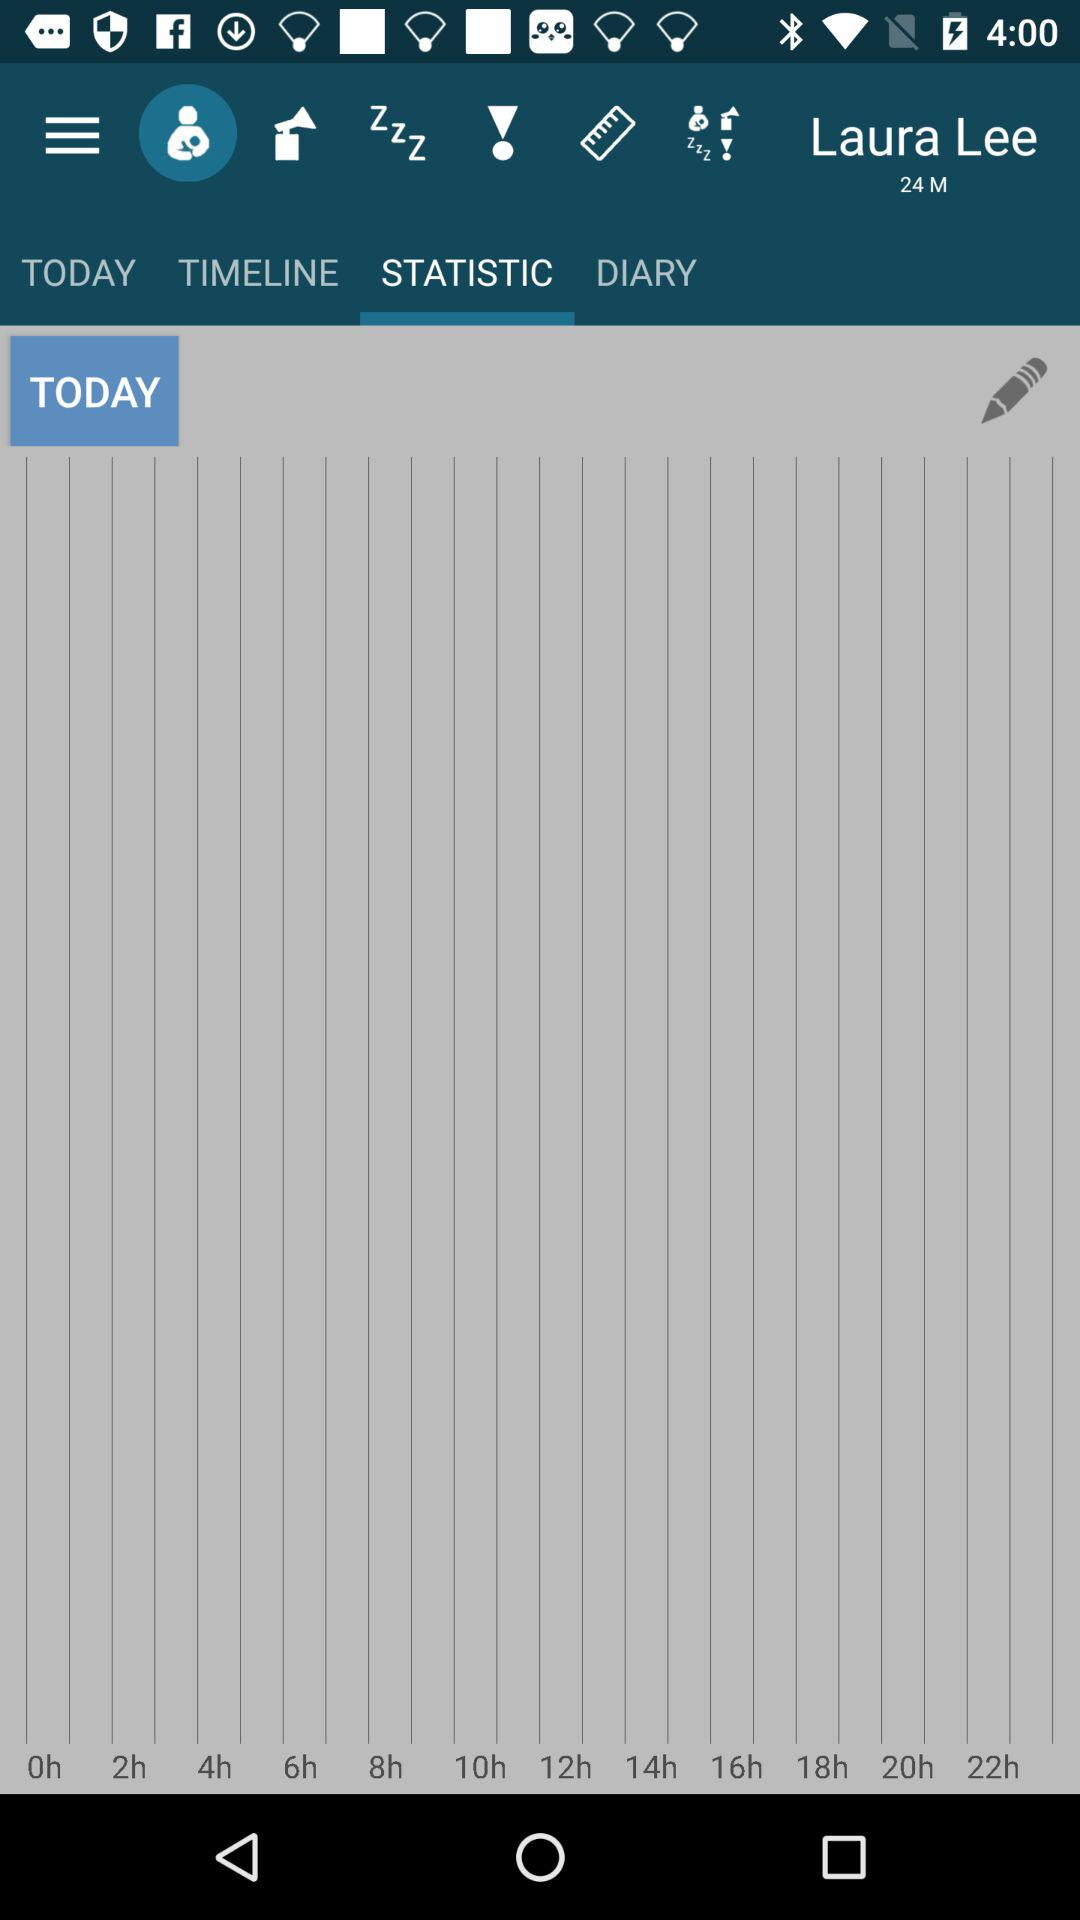How many hours are there between 18h and 10h?
Answer the question using a single word or phrase. 8 